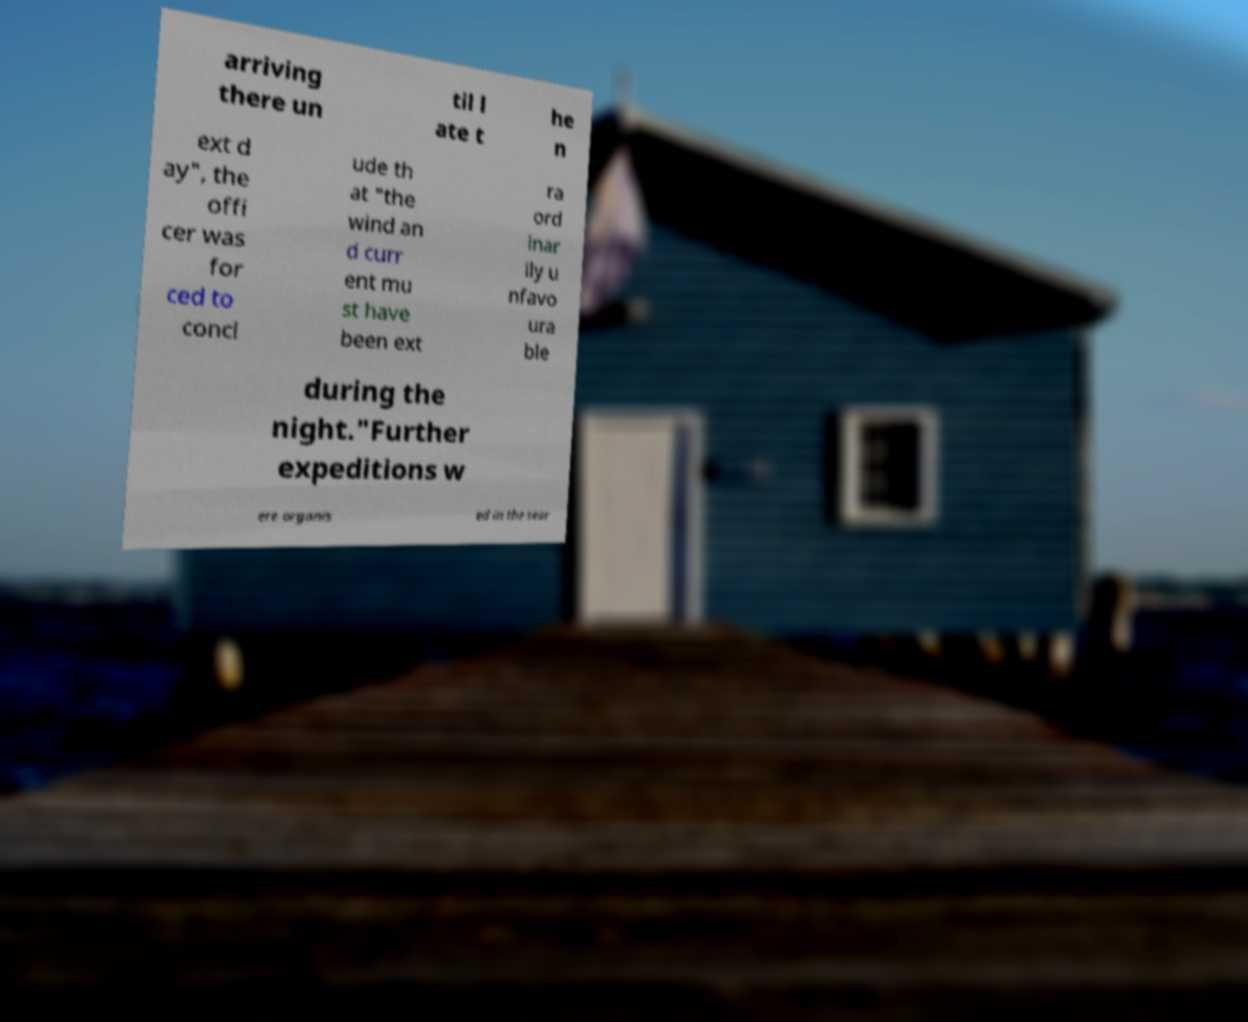Please read and relay the text visible in this image. What does it say? arriving there un til l ate t he n ext d ay", the offi cer was for ced to concl ude th at "the wind an d curr ent mu st have been ext ra ord inar ily u nfavo ura ble during the night."Further expeditions w ere organis ed in the sear 